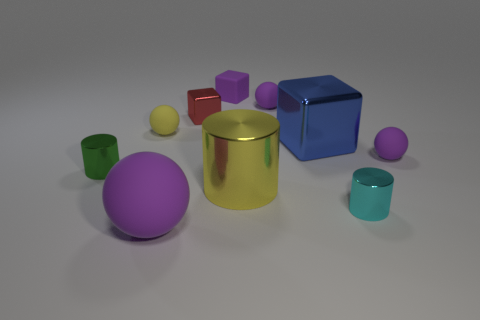Subtract all purple balls. How many were subtracted if there are1purple balls left? 2 Subtract all red cylinders. How many purple spheres are left? 3 Subtract all blocks. How many objects are left? 7 Subtract 0 yellow blocks. How many objects are left? 10 Subtract all purple shiny cylinders. Subtract all red metal things. How many objects are left? 9 Add 3 matte spheres. How many matte spheres are left? 7 Add 2 small matte cylinders. How many small matte cylinders exist? 2 